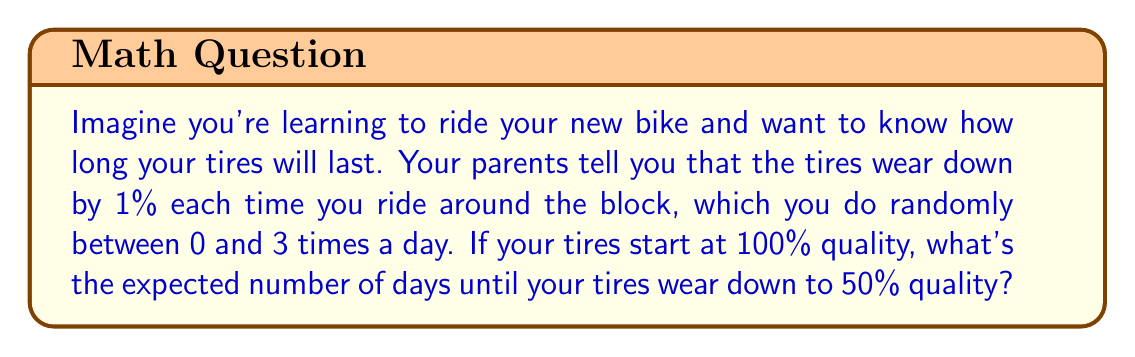Could you help me with this problem? Let's approach this step-by-step:

1) First, we need to calculate the average number of times you ride around the block each day:
   $E[\text{rides per day}] = \frac{0 + 1 + 2 + 3}{4} = 1.5$

2) Each ride reduces the tire quality by 1%, so on average, the daily reduction is:
   $1.5 \times 1\% = 1.5\%$

3) We can model this as a geometric process. The probability of the tires lasting another day is the probability that they don't wear down to 50% or below.

4) Let $X$ be the number of days until the tires reach 50% quality. We want to find $E[X]$.

5) The probability of lasting $n$ days is:
   $P(X > n) = P(\text{quality after n days} > 50\%)$
   $= P((1 - 0.015)^n > 0.5)$

6) Solving for $n$:
   $(1 - 0.015)^n = 0.5$
   $n \log(0.985) = \log(0.5)$
   $n = \frac{\log(0.5)}{\log(0.985)} \approx 45.74$

7) For a geometric distribution, $E[X] = \frac{1}{p}$, where $p$ is the probability of "success" on each trial. Here, success is the tires wearing down to 50%, which happens on average after 45.74 days.

8) Therefore, $E[X] = 45.74$ days.
Answer: 45.74 days 